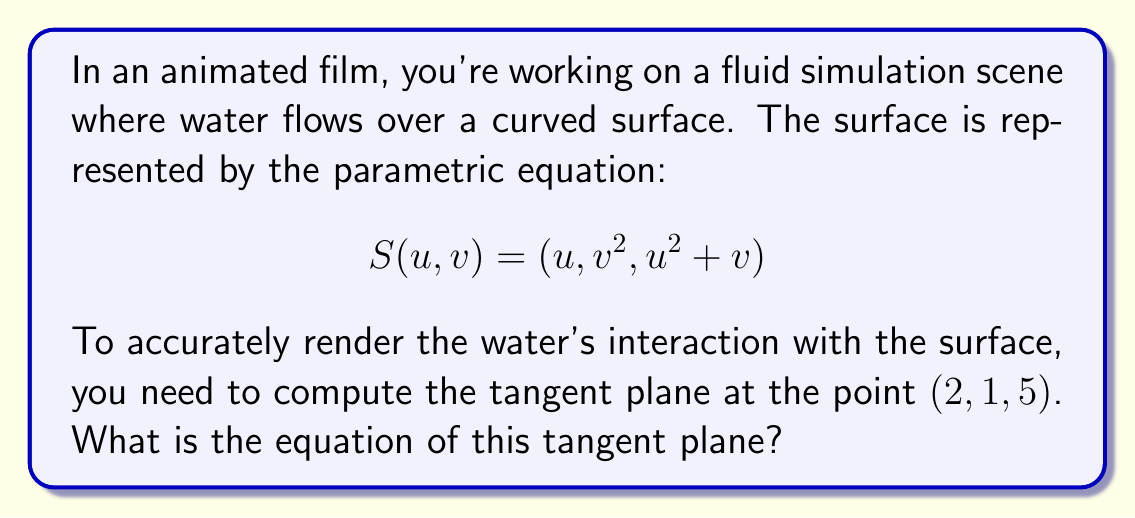Can you solve this math problem? To find the equation of the tangent plane, we'll follow these steps:

1) First, we need to find the partial derivatives of $S$ with respect to $u$ and $v$:

   $$S_u = \frac{\partial S}{\partial u} = (1, 0, 2u)$$
   $$S_v = \frac{\partial S}{\partial v} = (0, 2v, 1)$$

2) We need to find the $u$ and $v$ values that correspond to the point $(2, 1, 5)$:
   
   $u = 2$ (from the first coordinate)
   $v^2 = 1$, so $v = 1$ (from the second coordinate)
   
   We can verify: $u^2 + v = 2^2 + 1 = 5$ (which matches the third coordinate)

3) Now we can evaluate $S_u$ and $S_v$ at this point:

   $$S_u(2,1) = (1, 0, 4)$$
   $$S_v(2,1) = (0, 2, 1)$$

4) The normal vector to the tangent plane is the cross product of these vectors:

   $$N = S_u \times S_v = (1,0,4) \times (0,2,1) = (-8, -1, 2)$$

5) The equation of a plane with normal vector $(a,b,c)$ passing through point $(x_0,y_0,z_0)$ is:

   $$a(x-x_0) + b(y-y_0) + c(z-z_0) = 0$$

6) Substituting our values:

   $$-8(x-2) - 1(y-1) + 2(z-5) = 0$$

7) Simplifying:

   $$-8x+16 - y+1 + 2z-10 = 0$$
   $$-8x - y + 2z + 7 = 0$$
Answer: $-8x - y + 2z + 7 = 0$ 